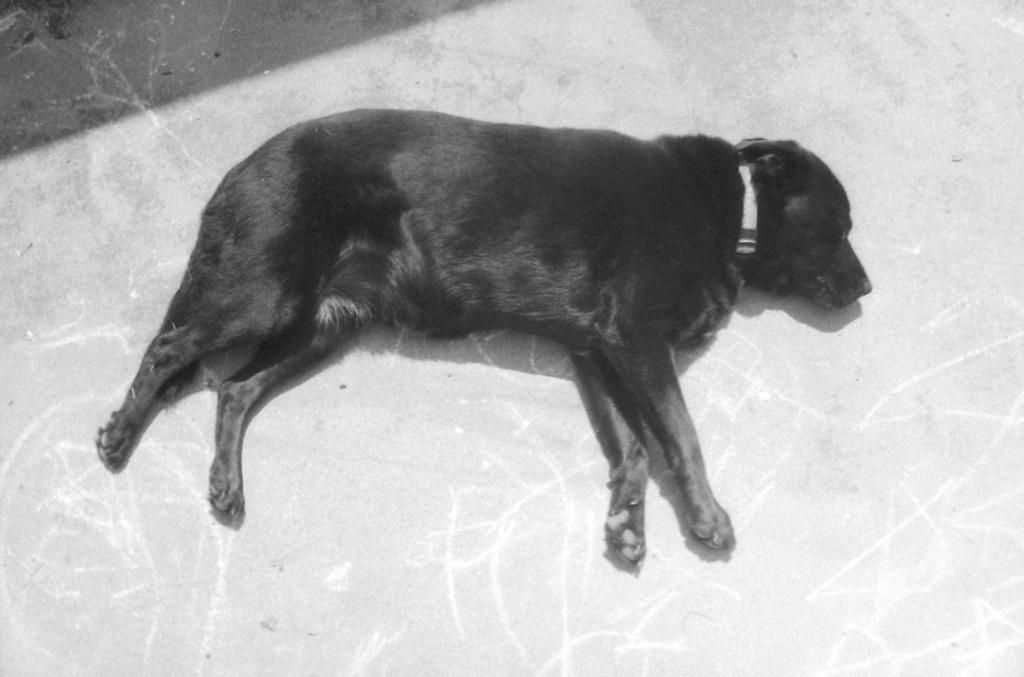What type of animal is in the image? There is a black dog in the image. Is there anything around the dog's neck? Yes, the dog has a white belt around its neck. What is the dog doing in the image? The dog is sleeping. Where is the dog located in the image? The dog is on the floor. What type of toothbrush is the dog using in the image? There is no toothbrush present in the image; the dog is sleeping and not using any toothbrush. 